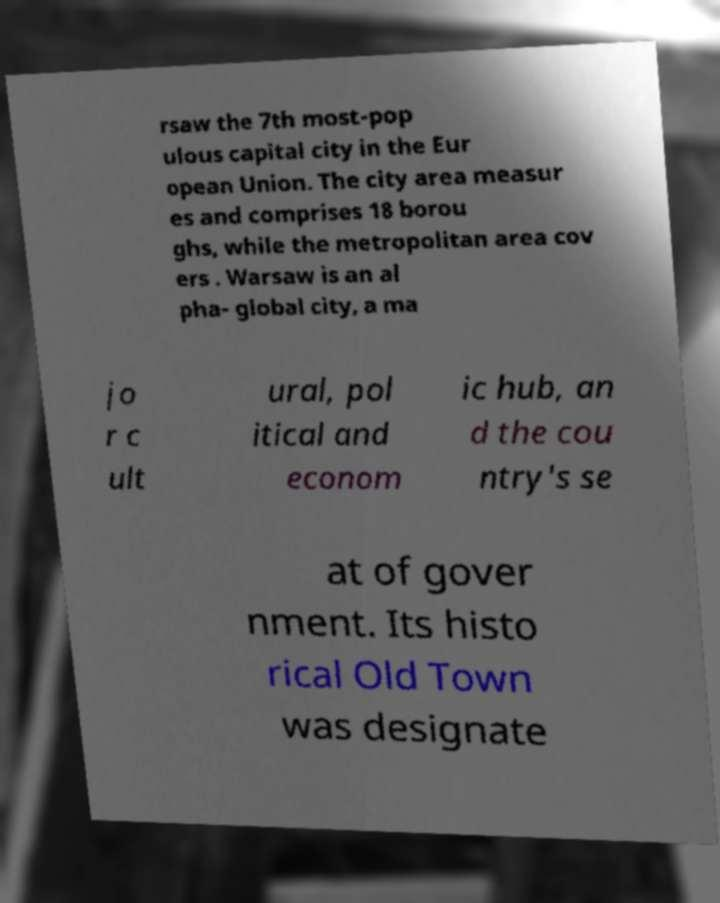What messages or text are displayed in this image? I need them in a readable, typed format. rsaw the 7th most-pop ulous capital city in the Eur opean Union. The city area measur es and comprises 18 borou ghs, while the metropolitan area cov ers . Warsaw is an al pha- global city, a ma jo r c ult ural, pol itical and econom ic hub, an d the cou ntry's se at of gover nment. Its histo rical Old Town was designate 